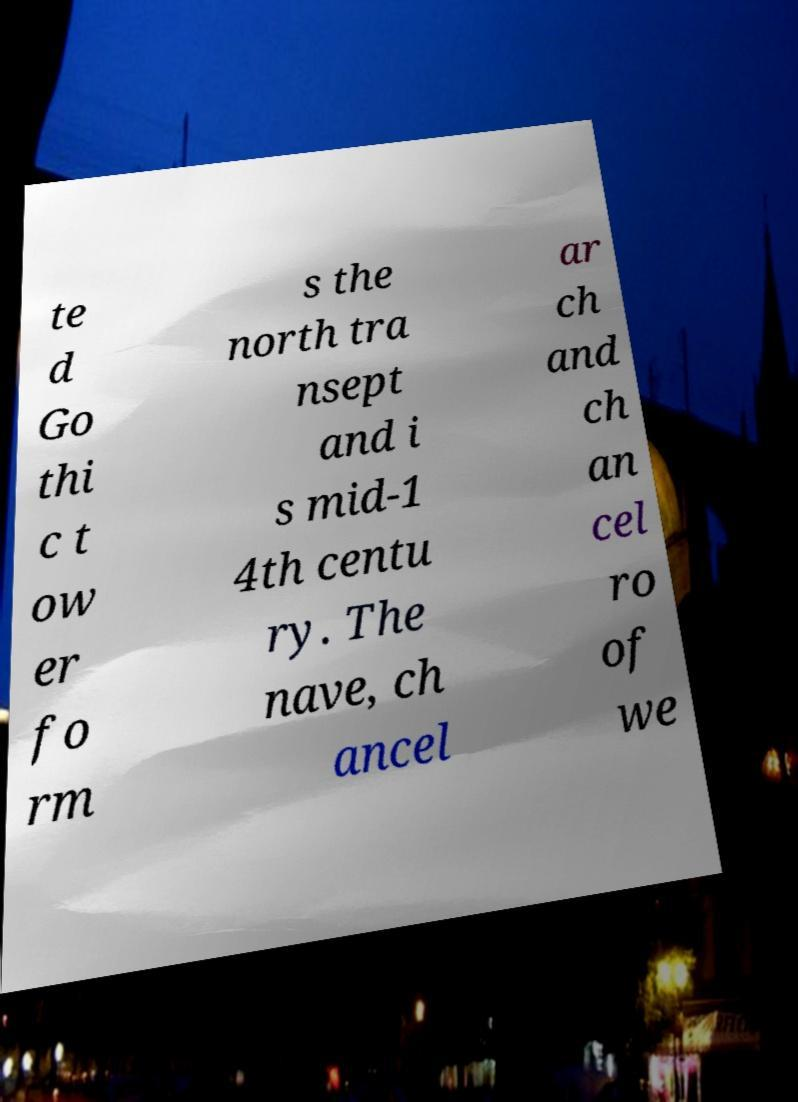For documentation purposes, I need the text within this image transcribed. Could you provide that? te d Go thi c t ow er fo rm s the north tra nsept and i s mid-1 4th centu ry. The nave, ch ancel ar ch and ch an cel ro of we 